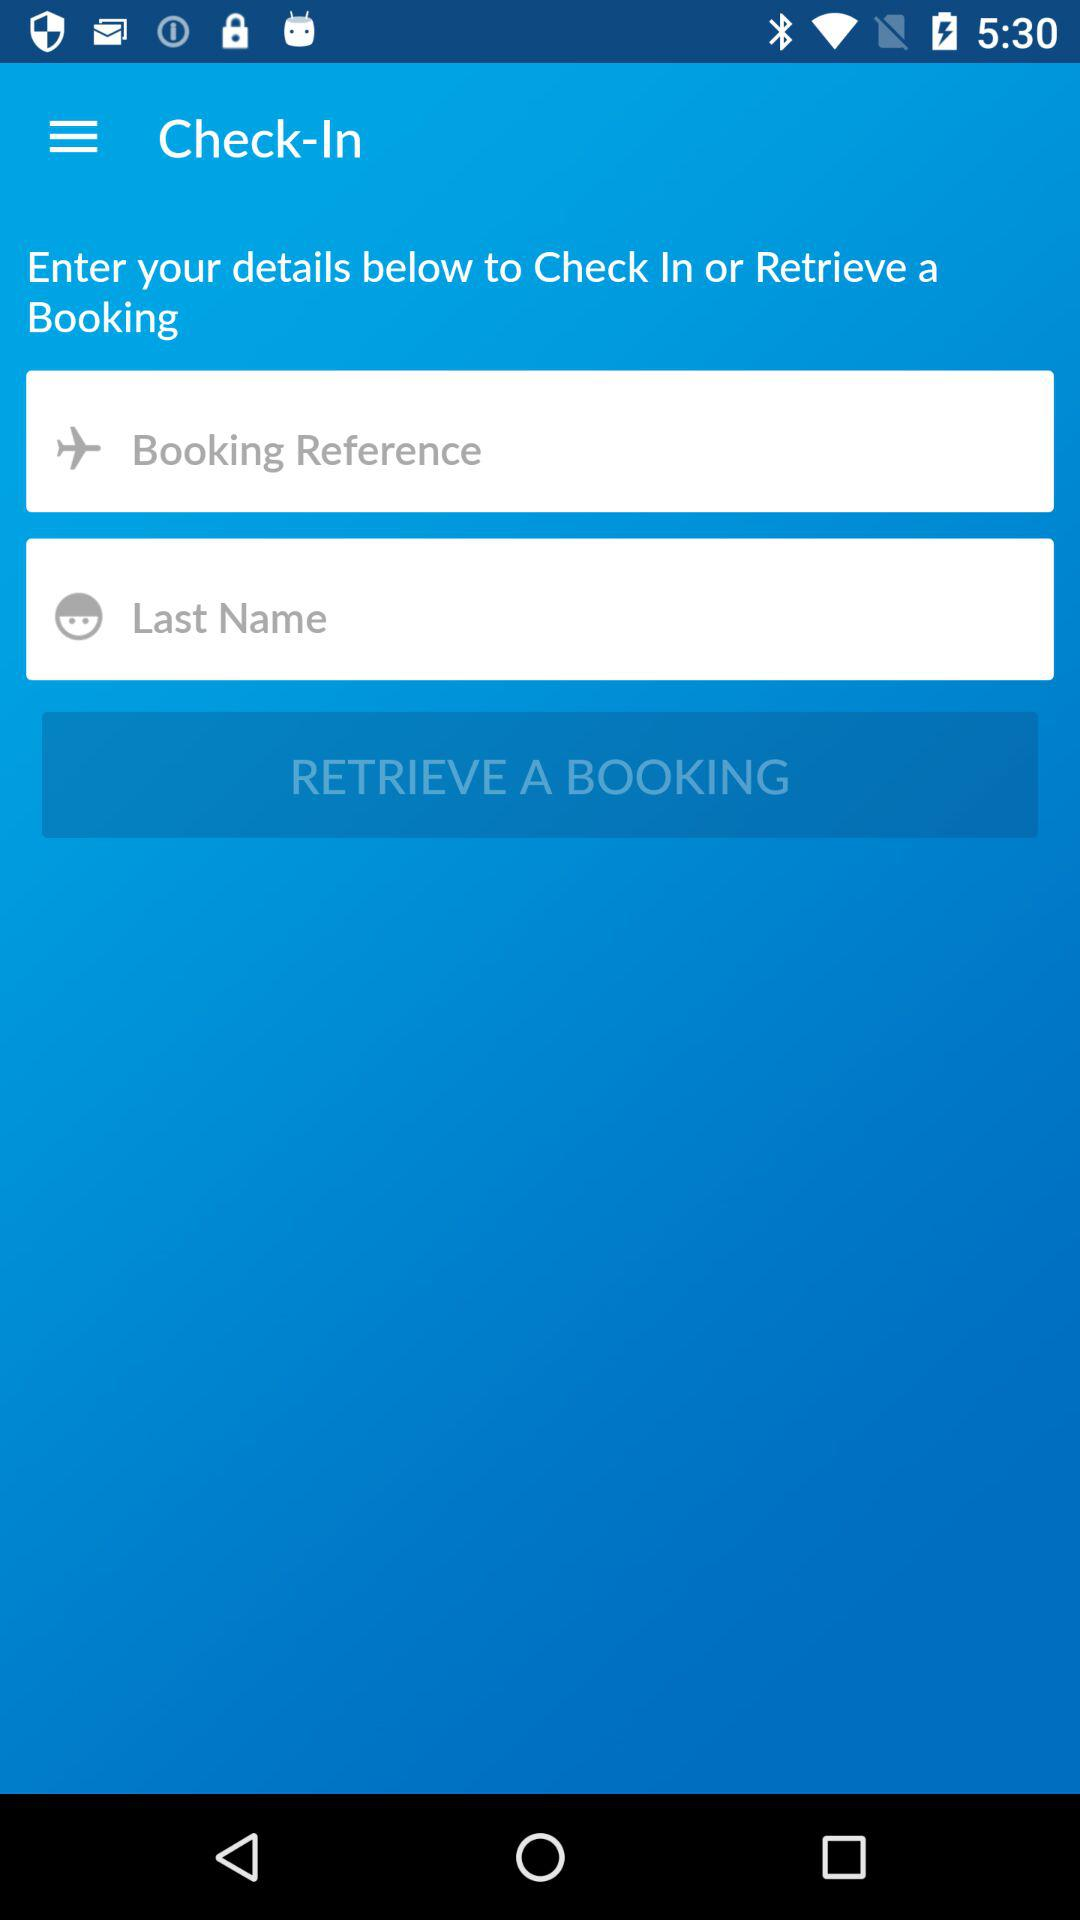How many fields do you need to fill out to retrieve a booking?
Answer the question using a single word or phrase. 2 